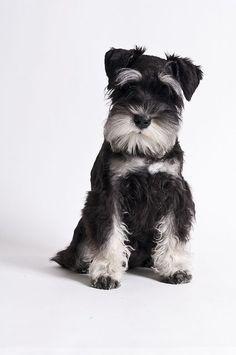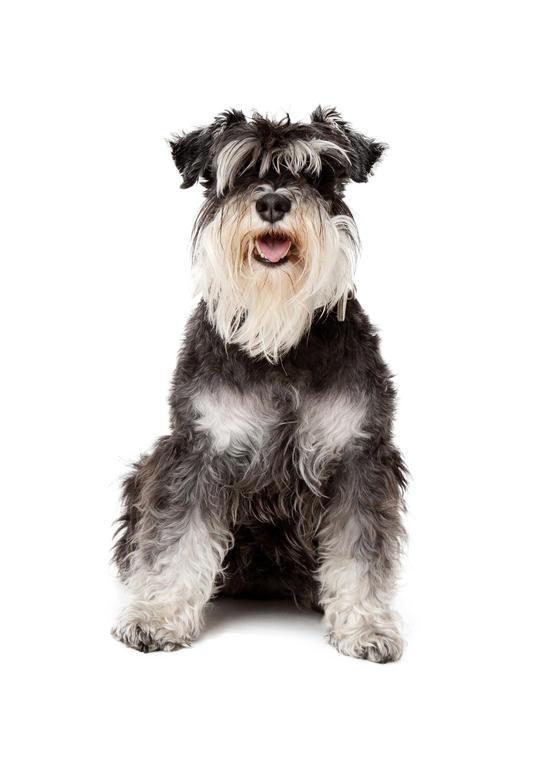The first image is the image on the left, the second image is the image on the right. Considering the images on both sides, is "One of the images shows a dog that is standing." valid? Answer yes or no. No. 